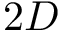Convert formula to latex. <formula><loc_0><loc_0><loc_500><loc_500>2 D</formula> 